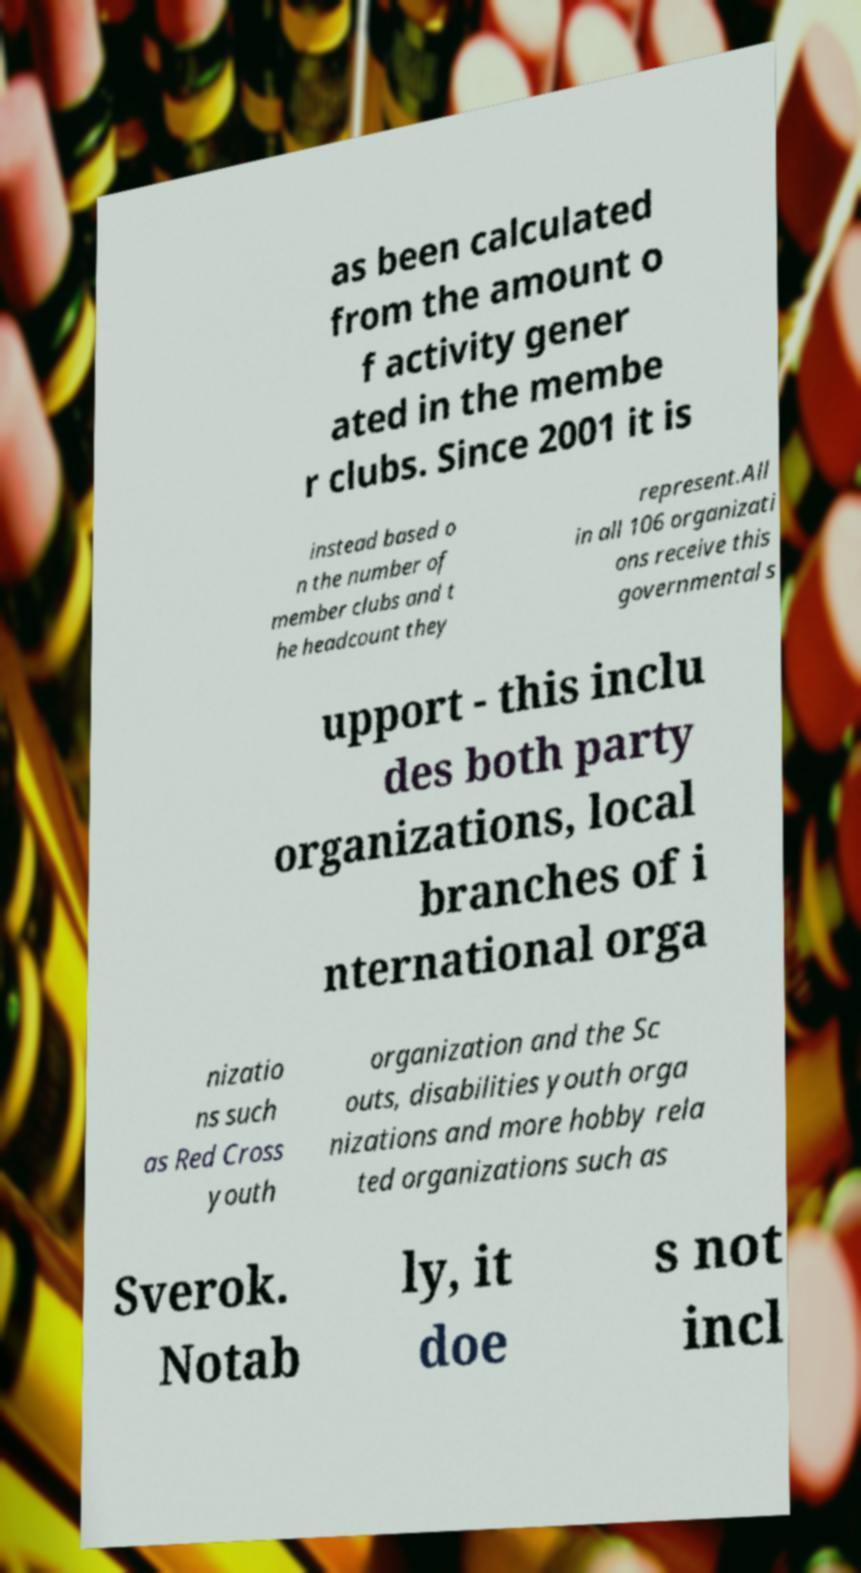What messages or text are displayed in this image? I need them in a readable, typed format. as been calculated from the amount o f activity gener ated in the membe r clubs. Since 2001 it is instead based o n the number of member clubs and t he headcount they represent.All in all 106 organizati ons receive this governmental s upport - this inclu des both party organizations, local branches of i nternational orga nizatio ns such as Red Cross youth organization and the Sc outs, disabilities youth orga nizations and more hobby rela ted organizations such as Sverok. Notab ly, it doe s not incl 